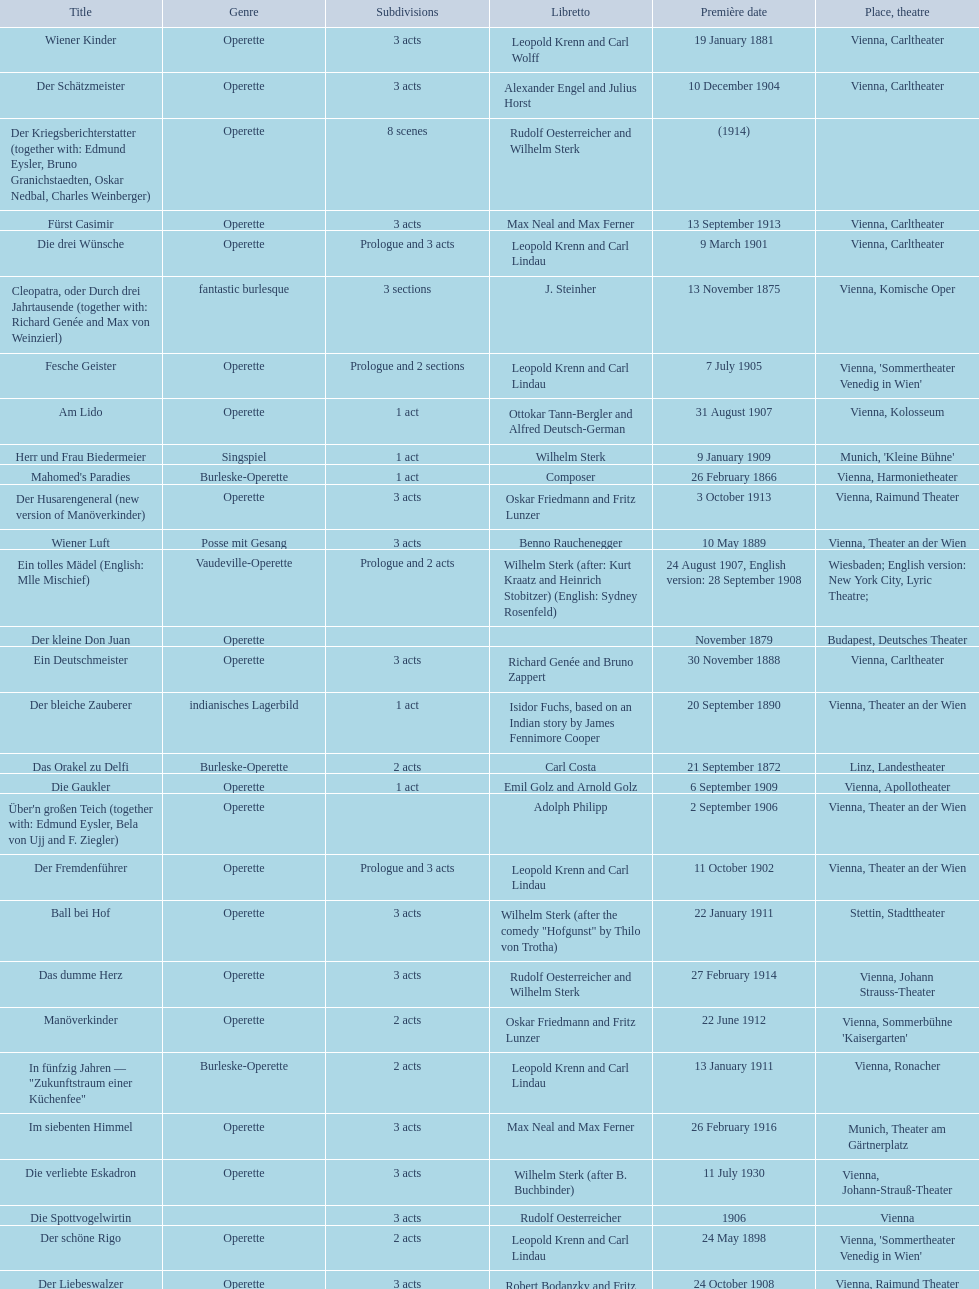What are the number of titles that premiered in the month of september? 4. Could you help me parse every detail presented in this table? {'header': ['Title', 'Genre', 'Sub\xaddivisions', 'Libretto', 'Première date', 'Place, theatre'], 'rows': [['Wiener Kinder', 'Operette', '3 acts', 'Leopold Krenn and Carl Wolff', '19 January 1881', 'Vienna, Carltheater'], ['Der Schätzmeister', 'Operette', '3 acts', 'Alexander Engel and Julius Horst', '10 December 1904', 'Vienna, Carltheater'], ['Der Kriegsberichterstatter (together with: Edmund Eysler, Bruno Granichstaedten, Oskar Nedbal, Charles Weinberger)', 'Operette', '8 scenes', 'Rudolf Oesterreicher and Wilhelm Sterk', '(1914)', ''], ['Fürst Casimir', 'Operette', '3 acts', 'Max Neal and Max Ferner', '13 September 1913', 'Vienna, Carltheater'], ['Die drei Wünsche', 'Operette', 'Prologue and 3 acts', 'Leopold Krenn and Carl Lindau', '9 March 1901', 'Vienna, Carltheater'], ['Cleopatra, oder Durch drei Jahrtausende (together with: Richard Genée and Max von Weinzierl)', 'fantastic burlesque', '3 sections', 'J. Steinher', '13 November 1875', 'Vienna, Komische Oper'], ['Fesche Geister', 'Operette', 'Prologue and 2 sections', 'Leopold Krenn and Carl Lindau', '7 July 1905', "Vienna, 'Sommertheater Venedig in Wien'"], ['Am Lido', 'Operette', '1 act', 'Ottokar Tann-Bergler and Alfred Deutsch-German', '31 August 1907', 'Vienna, Kolosseum'], ['Herr und Frau Biedermeier', 'Singspiel', '1 act', 'Wilhelm Sterk', '9 January 1909', "Munich, 'Kleine Bühne'"], ["Mahomed's Paradies", 'Burleske-Operette', '1 act', 'Composer', '26 February 1866', 'Vienna, Harmonietheater'], ['Der Husarengeneral (new version of Manöverkinder)', 'Operette', '3 acts', 'Oskar Friedmann and Fritz Lunzer', '3 October 1913', 'Vienna, Raimund Theater'], ['Wiener Luft', 'Posse mit Gesang', '3 acts', 'Benno Rauchenegger', '10 May 1889', 'Vienna, Theater an der Wien'], ['Ein tolles Mädel (English: Mlle Mischief)', 'Vaudeville-Operette', 'Prologue and 2 acts', 'Wilhelm Sterk (after: Kurt Kraatz and Heinrich Stobitzer) (English: Sydney Rosenfeld)', '24 August 1907, English version: 28 September 1908', 'Wiesbaden; English version: New York City, Lyric Theatre;'], ['Der kleine Don Juan', 'Operette', '', '', 'November 1879', 'Budapest, Deutsches Theater'], ['Ein Deutschmeister', 'Operette', '3 acts', 'Richard Genée and Bruno Zappert', '30 November 1888', 'Vienna, Carltheater'], ['Der bleiche Zauberer', 'indianisches Lagerbild', '1 act', 'Isidor Fuchs, based on an Indian story by James Fennimore Cooper', '20 September 1890', 'Vienna, Theater an der Wien'], ['Das Orakel zu Delfi', 'Burleske-Operette', '2 acts', 'Carl Costa', '21 September 1872', 'Linz, Landestheater'], ['Die Gaukler', 'Operette', '1 act', 'Emil Golz and Arnold Golz', '6 September 1909', 'Vienna, Apollotheater'], ["Über'n großen Teich (together with: Edmund Eysler, Bela von Ujj and F. Ziegler)", 'Operette', '', 'Adolph Philipp', '2 September 1906', 'Vienna, Theater an der Wien'], ['Der Fremdenführer', 'Operette', 'Prologue and 3 acts', 'Leopold Krenn and Carl Lindau', '11 October 1902', 'Vienna, Theater an der Wien'], ['Ball bei Hof', 'Operette', '3 acts', 'Wilhelm Sterk (after the comedy "Hofgunst" by Thilo von Trotha)', '22 January 1911', 'Stettin, Stadttheater'], ['Das dumme Herz', 'Operette', '3 acts', 'Rudolf Oesterreicher and Wilhelm Sterk', '27 February 1914', 'Vienna, Johann Strauss-Theater'], ['Manöverkinder', 'Operette', '2 acts', 'Oskar Friedmann and Fritz Lunzer', '22 June 1912', "Vienna, Sommerbühne 'Kaisergarten'"], ['In fünfzig Jahren — "Zukunftstraum einer Küchenfee"', 'Burleske-Operette', '2 acts', 'Leopold Krenn and Carl Lindau', '13 January 1911', 'Vienna, Ronacher'], ['Im siebenten Himmel', 'Operette', '3 acts', 'Max Neal and Max Ferner', '26 February 1916', 'Munich, Theater am Gärtnerplatz'], ['Die verliebte Eskadron', 'Operette', '3 acts', 'Wilhelm Sterk (after B. Buchbinder)', '11 July 1930', 'Vienna, Johann-Strauß-Theater'], ['Die Spottvogelwirtin', '', '3 acts', 'Rudolf Oesterreicher', '1906', 'Vienna'], ['Der schöne Rigo', 'Operette', '2 acts', 'Leopold Krenn and Carl Lindau', '24 May 1898', "Vienna, 'Sommertheater Venedig in Wien'"], ['Der Liebeswalzer', 'Operette', '3 acts', 'Robert Bodanzky and Fritz Grünbaum', '24 October 1908', 'Vienna, Raimund Theater'], ['Deutschmeisterkapelle', 'Operette', '', 'Hubert Marischka and Rudolf Oesterreicher', '30 May 1958', 'Vienna, Raimund Theater'], ['König Jérôme oder Immer lustick!', 'Operette', '4 acts', 'Adolf Schirmer', '28 November 1878', 'Vienna, Ringtheater'], ['Die Landstreicher', 'Operette', 'Prologue and 2 acts', 'Leopold Krenn and Carl Lindau', '26 July 1899', "Vienna, 'Sommertheater Venedig in Wien'"]]} 